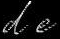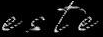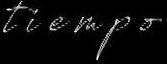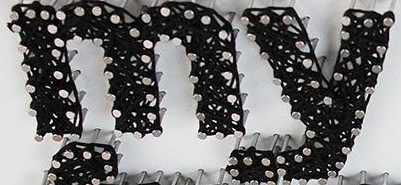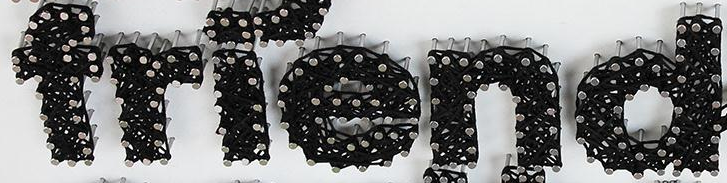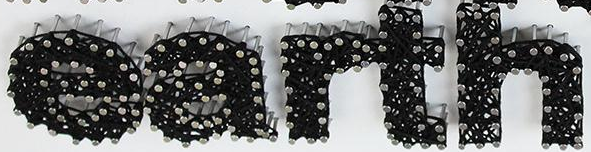Read the text content from these images in order, separated by a semicolon. de; este; tiempo; my; friend; earth 